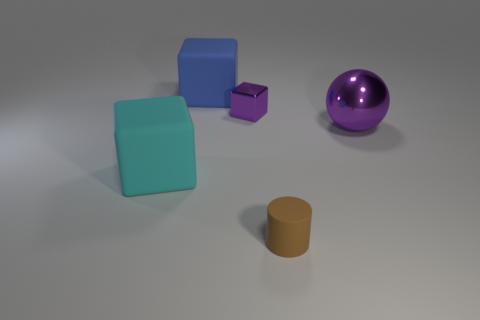Are the cylinder and the big block that is behind the purple shiny ball made of the same material?
Offer a very short reply. Yes. There is a large matte thing that is right of the cyan matte object; are there any tiny purple things that are behind it?
Make the answer very short. No. The object that is both behind the sphere and to the right of the large blue matte block is what color?
Provide a short and direct response. Purple. What size is the shiny ball?
Make the answer very short. Large. How many purple metal blocks have the same size as the brown thing?
Your response must be concise. 1. Do the purple thing that is right of the cylinder and the small thing behind the tiny brown rubber cylinder have the same material?
Ensure brevity in your answer.  Yes. What is the material of the large cube on the left side of the large rubber block behind the small block?
Your answer should be very brief. Rubber. What material is the large object to the right of the big blue rubber object?
Your answer should be compact. Metal. What number of other metal things are the same shape as the large purple thing?
Your response must be concise. 0. Does the small metallic cube have the same color as the large metal object?
Ensure brevity in your answer.  Yes. 